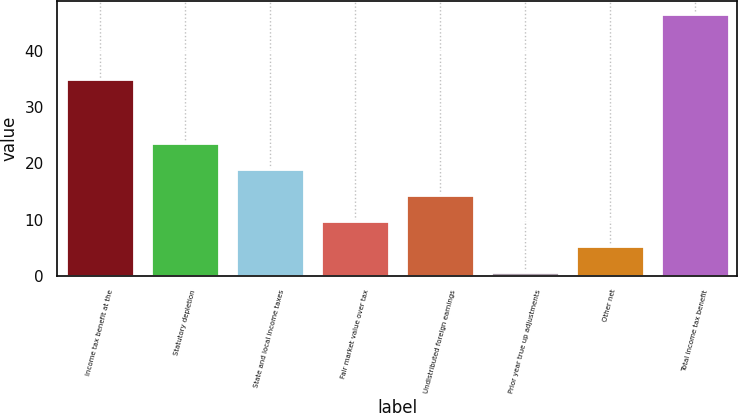Convert chart to OTSL. <chart><loc_0><loc_0><loc_500><loc_500><bar_chart><fcel>Income tax benefit at the<fcel>Statutory depletion<fcel>State and local income taxes<fcel>Fair market value over tax<fcel>Undistributed foreign earnings<fcel>Prior year true up adjustments<fcel>Other net<fcel>Total income tax benefit<nl><fcel>35<fcel>23.6<fcel>19<fcel>9.8<fcel>14.4<fcel>0.6<fcel>5.2<fcel>46.6<nl></chart> 